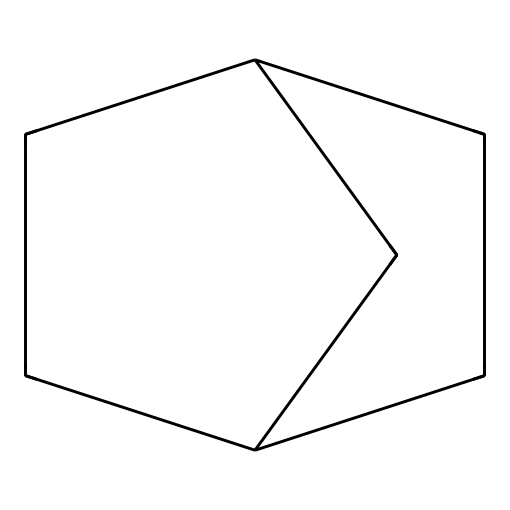What is the common name of this compound? The SMILES representation shows a bicyclic structure that corresponds to norbornane, a well-known bicyclic alkane.
Answer: norbornane How many carbons are present in this compound? In the structure, we can count 10 carbon atoms in total, which agree with the molecular formula C10H16.
Answer: 10 What is the degree of saturation for this compound? The structure is a bicyclic alkane with two rings, the degree of saturation can be calculated using the formula (2C + 2 - H)/2. Here, C=10, H=16 gives us a degree of saturation of 4.
Answer: 4 Is this compound a cyclic or acyclic hydrocarbon? The visual structure indicates that it contains rings, making it a cyclic hydrocarbon as per its definition.
Answer: cyclic How many hydrogen atoms are bonded to the central carbon atoms in the structure? By analyzing the structure, the central carbon atoms are bonded to a total of 12 hydrogen atoms, evident from the balance of valences in the cyclic compounds.
Answer: 12 What kind of isomerism can norbornane exhibit? Norbornane exhibits stereoisomerism due to the fixed ring structure, which doesn't allow for rotation between the bonds of the cycles.
Answer: stereoisomerism What is the significance of norbornane in pharmacology? Norbornane has important implications in pharmaceutical chemistry due to its structural similarity with many biologically active compounds, enhancing drug design and development.
Answer: pharmaceutical relevance 